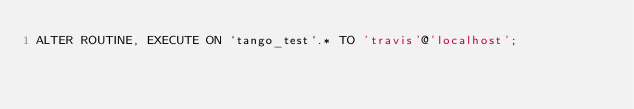<code> <loc_0><loc_0><loc_500><loc_500><_SQL_>ALTER ROUTINE, EXECUTE ON `tango_test`.* TO 'travis'@'localhost';
</code> 